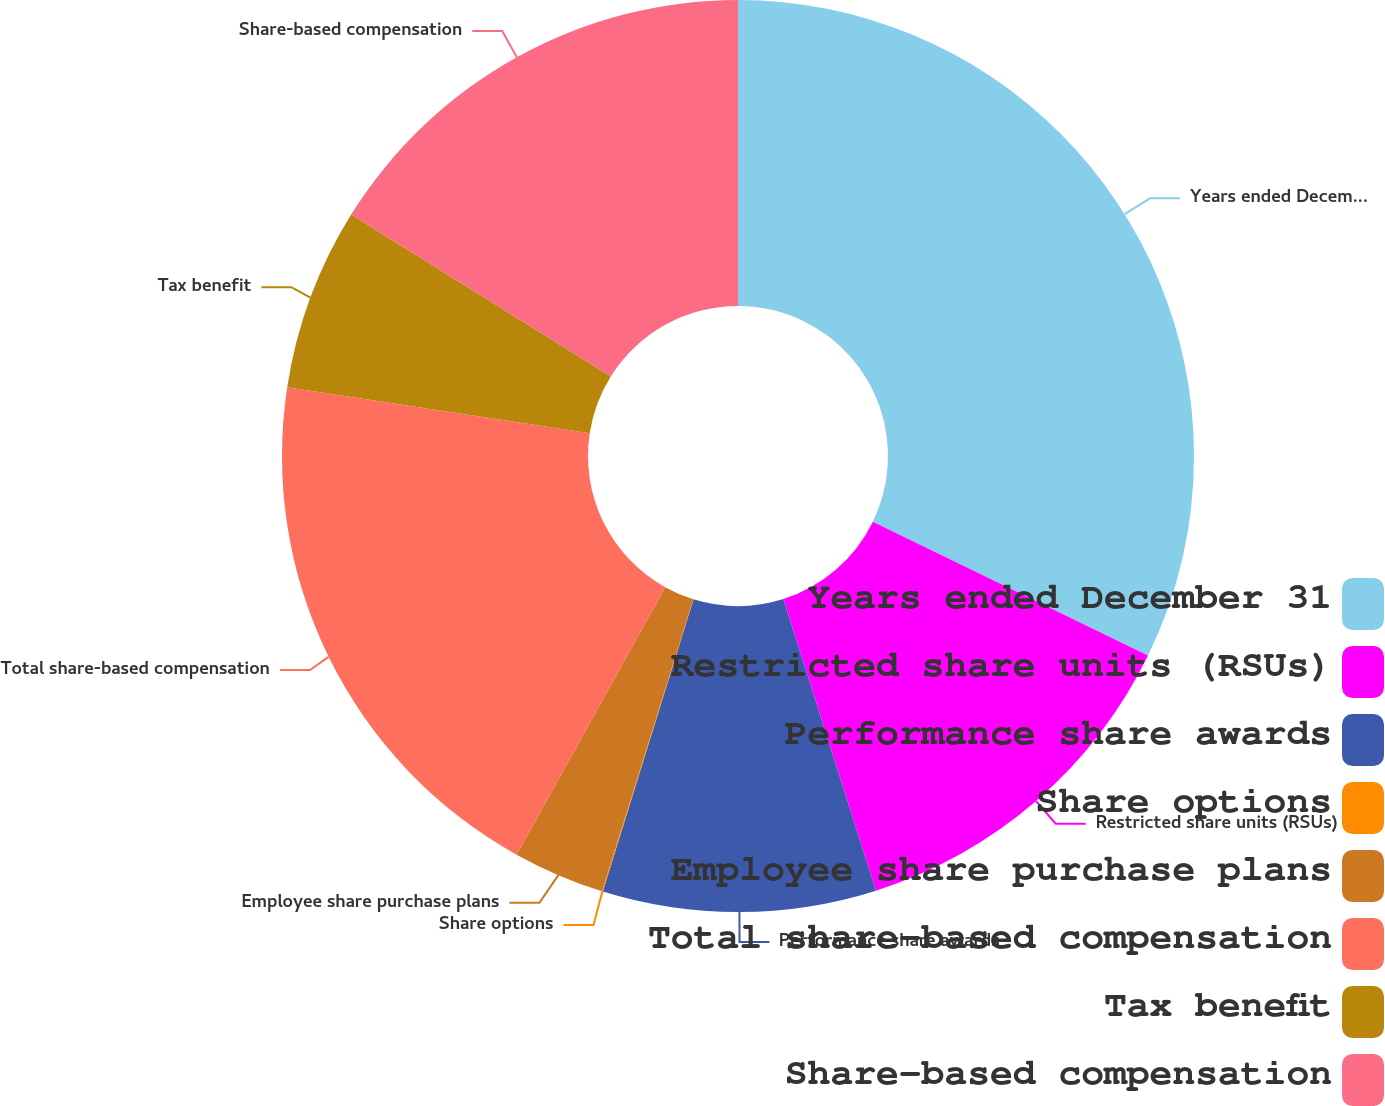Convert chart to OTSL. <chart><loc_0><loc_0><loc_500><loc_500><pie_chart><fcel>Years ended December 31<fcel>Restricted share units (RSUs)<fcel>Performance share awards<fcel>Share options<fcel>Employee share purchase plans<fcel>Total share-based compensation<fcel>Tax benefit<fcel>Share-based compensation<nl><fcel>32.21%<fcel>12.9%<fcel>9.68%<fcel>0.03%<fcel>3.25%<fcel>19.34%<fcel>6.47%<fcel>16.12%<nl></chart> 